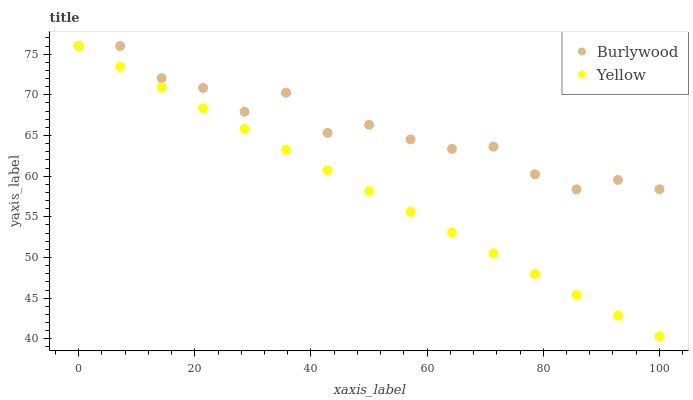Does Yellow have the minimum area under the curve?
Answer yes or no. Yes. Does Burlywood have the maximum area under the curve?
Answer yes or no. Yes. Does Yellow have the maximum area under the curve?
Answer yes or no. No. Is Yellow the smoothest?
Answer yes or no. Yes. Is Burlywood the roughest?
Answer yes or no. Yes. Is Yellow the roughest?
Answer yes or no. No. Does Yellow have the lowest value?
Answer yes or no. Yes. Does Yellow have the highest value?
Answer yes or no. Yes. Does Burlywood intersect Yellow?
Answer yes or no. Yes. Is Burlywood less than Yellow?
Answer yes or no. No. Is Burlywood greater than Yellow?
Answer yes or no. No. 